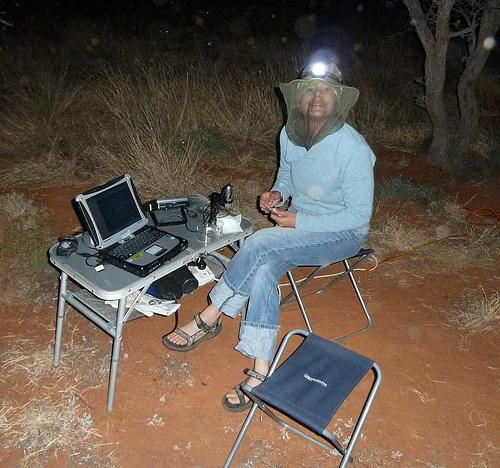What is the central action happening in the image, and how would you describe the subject? A well-prepared woman is seated outdoors working with computer equipment while wearing a blue shirt, jeans, sandals, a beekeeper mask, and a lit headlight on her hat. Briefly describe the scene in the image, focusing on the person and their surroundings. A woman wearing protective gear sits outdoors with a laptop on a small table, surrounded by tall grass and trees, with a moonlit sky overhead. What is the person in the photo doing, and what clothing and accessories are they wearing? The woman is sitting with a laptop outside, wearing a blue shirt, jeans, sandals, and a hat with attached bug net and headlight. What primary elements in the image reveal the woman's actions and her surroundings? A woman sitting with computer equipment wears a blue shirt, jeans, and protective gear, surrounded by grass, trees, and a night sky with a visible moon and stars. Provide a snapshot description of the woman, her appearance, and the context within the image. A female in a blue sweater, jeans, and bug netting sits outside at night with computer equipment, surrounded by grass, trees, and a moonlit night. Provide a concise description of the central figure in the image and their current activity. A woman in a blue sweater wearing a beekeeper mask is sitting outside with computer equipment on a foldable table. Briefly depict the subject of the image and the essential details about her outfit and environment. An interesting lady using computer equipment outside wears a blue sweater, jeans, sandals, and protective headgear, surrounded by a serene scene of grass, trees, and a starry sky. Using descriptive language, paint a picture of the woman in the image and the setting she is in. A resolute woman dons a blue sweater, jeans, and protective gear while engaging with computer equipment outdoors, among the quiet rustling of grass, trees, and a starry sky. Explain the situation of the woman in the image and mention her attire and surrounding elements. A lady wearing a blue shirt, jeans, sandals, a beekeeper mask, and a lit headlight is sitting outside with a laptop on a folding table, amidst grass, trees, and a nighttime sky. Describe the woman and her outdoor environment as captured in the image. The image portrays a determined woman garbed in a blue sweater, jeans, sandals, and bug netting as she operates computer equipment surrounded by a mysterious nighttime landscape. 